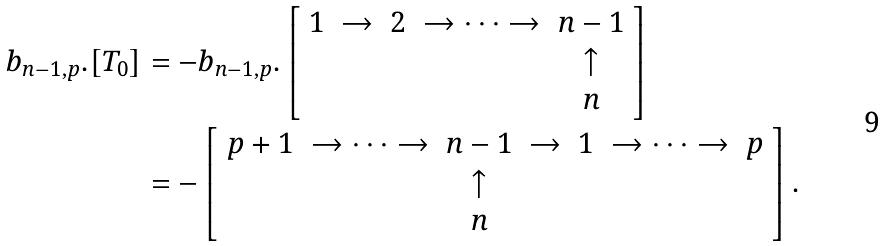<formula> <loc_0><loc_0><loc_500><loc_500>b _ { n - 1 , p } . [ T _ { 0 } ] & = - b _ { n - 1 , p } . \left [ \begin{array} { c c c c c } 1 & \to & 2 & \to \cdots \to & n - 1 \\ & & & & \uparrow \\ & & & & n \end{array} \right ] \\ & = - \left [ \begin{array} { c c c c c c c } p + 1 & \to \cdots \to & n - 1 & \to & 1 & \to \cdots \to & p \\ & & \uparrow & & & & \\ & & n & & & & \end{array} \right ] .</formula> 